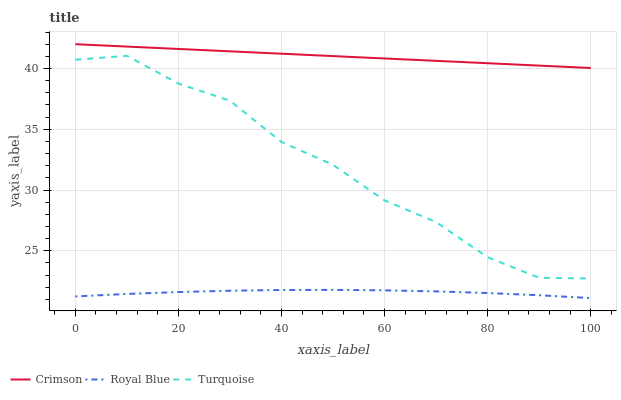Does Royal Blue have the minimum area under the curve?
Answer yes or no. Yes. Does Crimson have the maximum area under the curve?
Answer yes or no. Yes. Does Turquoise have the minimum area under the curve?
Answer yes or no. No. Does Turquoise have the maximum area under the curve?
Answer yes or no. No. Is Crimson the smoothest?
Answer yes or no. Yes. Is Turquoise the roughest?
Answer yes or no. Yes. Is Royal Blue the smoothest?
Answer yes or no. No. Is Royal Blue the roughest?
Answer yes or no. No. Does Royal Blue have the lowest value?
Answer yes or no. Yes. Does Turquoise have the lowest value?
Answer yes or no. No. Does Crimson have the highest value?
Answer yes or no. Yes. Does Turquoise have the highest value?
Answer yes or no. No. Is Royal Blue less than Crimson?
Answer yes or no. Yes. Is Crimson greater than Royal Blue?
Answer yes or no. Yes. Does Royal Blue intersect Crimson?
Answer yes or no. No. 